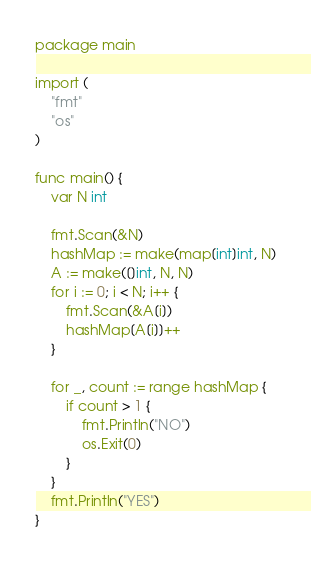<code> <loc_0><loc_0><loc_500><loc_500><_Go_>package main
 
import (
	"fmt"
	"os"
)
 
func main() {
	var N int
 
	fmt.Scan(&N)
	hashMap := make(map[int]int, N)
	A := make([]int, N, N)
	for i := 0; i < N; i++ {
		fmt.Scan(&A[i])
		hashMap[A[i]]++
	}
 
	for _, count := range hashMap {
		if count > 1 {
			fmt.Println("NO")
			os.Exit(0)
		}
	}
	fmt.Println("YES")
}</code> 